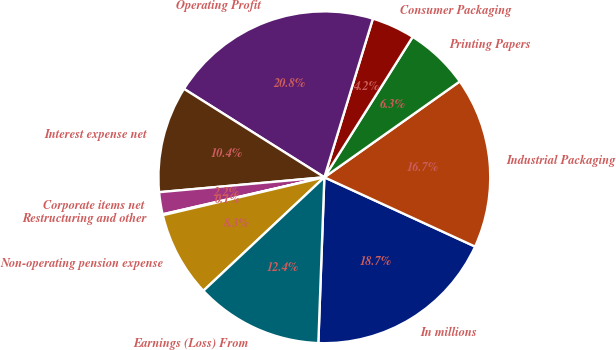<chart> <loc_0><loc_0><loc_500><loc_500><pie_chart><fcel>In millions<fcel>Industrial Packaging<fcel>Printing Papers<fcel>Consumer Packaging<fcel>Operating Profit<fcel>Interest expense net<fcel>Corporate items net<fcel>Restructuring and other<fcel>Non-operating pension expense<fcel>Earnings (Loss) From<nl><fcel>18.72%<fcel>16.66%<fcel>6.26%<fcel>4.21%<fcel>20.78%<fcel>10.38%<fcel>2.15%<fcel>0.09%<fcel>8.32%<fcel>12.43%<nl></chart> 